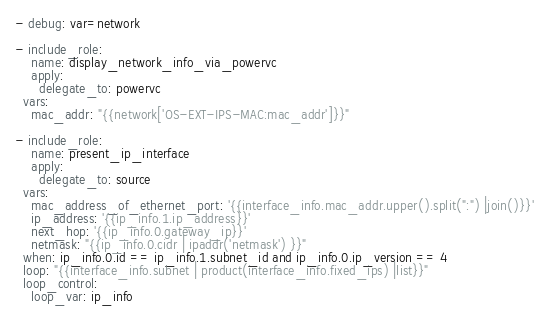Convert code to text. <code><loc_0><loc_0><loc_500><loc_500><_YAML_>- debug: var=network

- include_role: 
    name: display_network_info_via_powervc
    apply:
      delegate_to: powervc
  vars: 
    mac_addr: "{{network['OS-EXT-IPS-MAC:mac_addr']}}"

- include_role:
    name: present_ip_interface
    apply:
      delegate_to: source
  vars:
    mac_address_of_ethernet_port: '{{interface_info.mac_addr.upper().split(":") |join()}}'
    ip_address: '{{ip_info.1.ip_address}}'
    next_hop: '{{ip_info.0.gateway_ip}}'
    netmask: "{{ip_info.0.cidr | ipaddr('netmask') }}"
  when: ip_info.0.id == ip_info.1.subnet_id and ip_info.0.ip_version == 4 
  loop: "{{interface_info.subnet | product(interface_info.fixed_ips) |list}}"
  loop_control:
    loop_var: ip_info</code> 